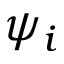Convert formula to latex. <formula><loc_0><loc_0><loc_500><loc_500>\psi _ { i }</formula> 